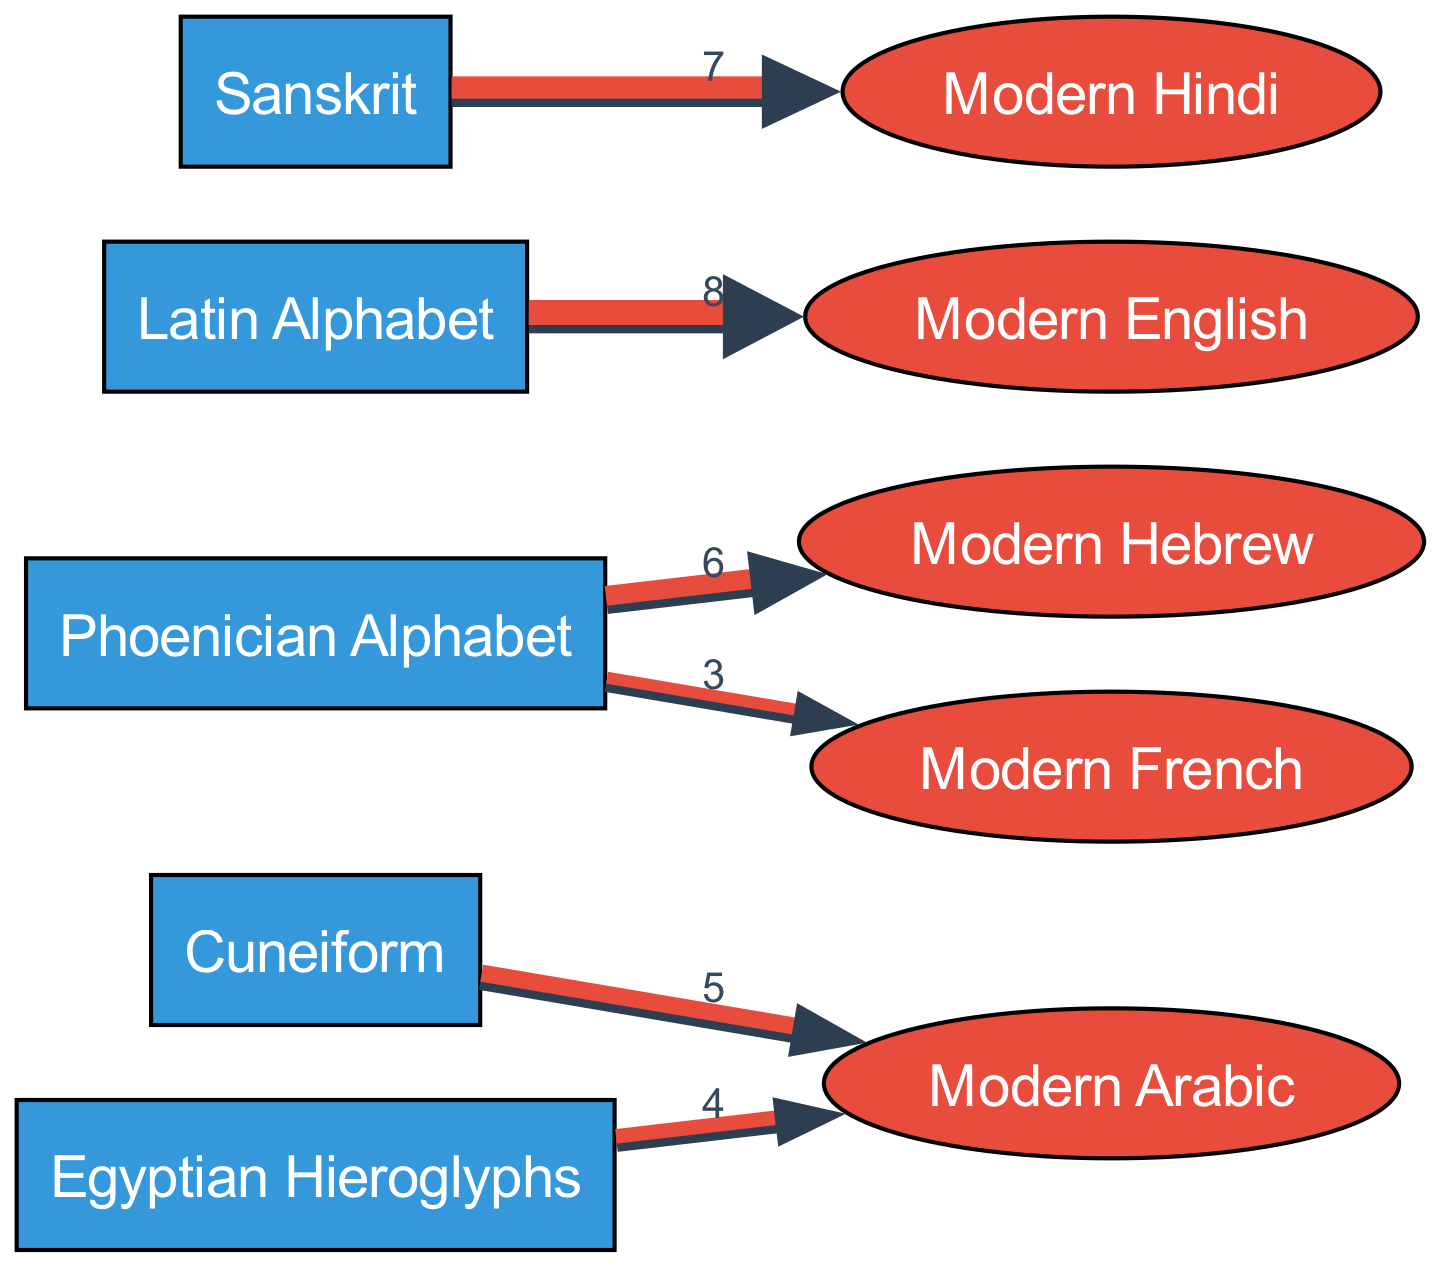What is the value of the influence from Cuneiform to Modern Arabic? The diagram shows a direct link from Cuneiform to Modern Arabic, with a value of 5 indicated next to the connecting arrow.
Answer: 5 Which ancient script has the highest influence on Modern English? The diagram indicates a strong influence from the Latin Alphabet to Modern English, represented by the highest value of 8 next to their connecting arrow.
Answer: Latin Alphabet How many different scripts are represented in the diagram? By counting the nodes labeled as scripts, we find that there are a total of 5 scripts included in the diagram.
Answer: 5 Which modern language derives directly from Sanskrit? The arrow from Sanskrit points directly towards Modern Hindi, indicating that Modern Hindi is influenced by Sanskrit.
Answer: Modern Hindi What is the total influence value from the Phoenician Alphabet to its modern languages? The total influence can be obtained by summing the values from the Phoenician Alphabet to both Modern Hebrew (6) and Modern French (3), resulting in a total influence of 9.
Answer: 9 Which modern language shows the least influence from ancient scripts? By examining the diagram, the arrow with the lowest connecting value to a modern language is Modern French, which has a value of 3 from the Phoenician Alphabet.
Answer: Modern French How does the influence of Egyptian Hieroglyphs compare to that of Cuneiform on Modern Arabic? We observe that Egyptian Hieroglyphs connect to Modern Arabic with a value of 4, while Cuneiform has a higher connection value of 5 to the same language; therefore, Cuneiform has a stronger influence.
Answer: Cuneiform Which modern language receives the highest influence value from Sanskrit? The arrow stemming from Sanskrit leads to Modern Hindi, which has an influence value of 7, indicating it receives the highest influence from Sanskrit.
Answer: Modern Hindi Is there any direct influence of Cuneiform on Modern English? Upon reviewing the connecting arrows in the diagram, there is no direct line or connection from Cuneiform to Modern English, indicating no influence.
Answer: No 